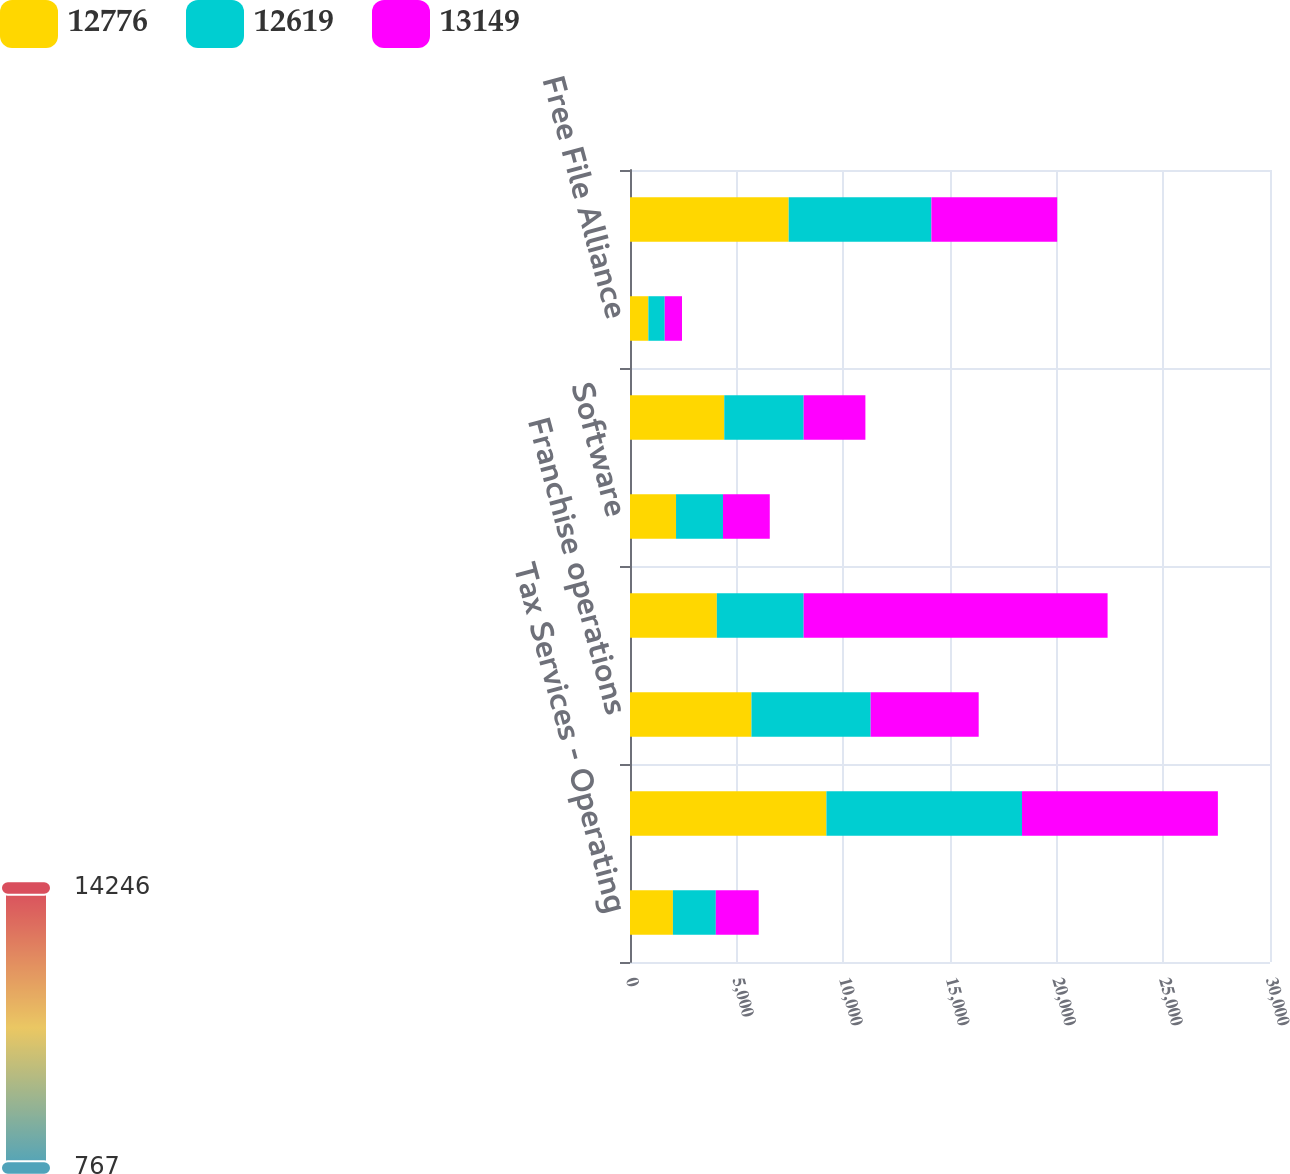<chart> <loc_0><loc_0><loc_500><loc_500><stacked_bar_chart><ecel><fcel>Tax Services - Operating<fcel>Company-owned operations<fcel>Franchise operations<fcel>Total retail operations<fcel>Software<fcel>Online<fcel>Free File Alliance<fcel>Total digital tax solutions<nl><fcel>12776<fcel>2012<fcel>9207<fcel>5693<fcel>4070.5<fcel>2158<fcel>4419<fcel>861<fcel>7438<nl><fcel>12619<fcel>2011<fcel>9168<fcel>5588<fcel>4070.5<fcel>2201<fcel>3722<fcel>767<fcel>6690<nl><fcel>13149<fcel>2010<fcel>9182<fcel>5064<fcel>14246<fcel>2193<fcel>2893<fcel>810<fcel>5896<nl></chart> 